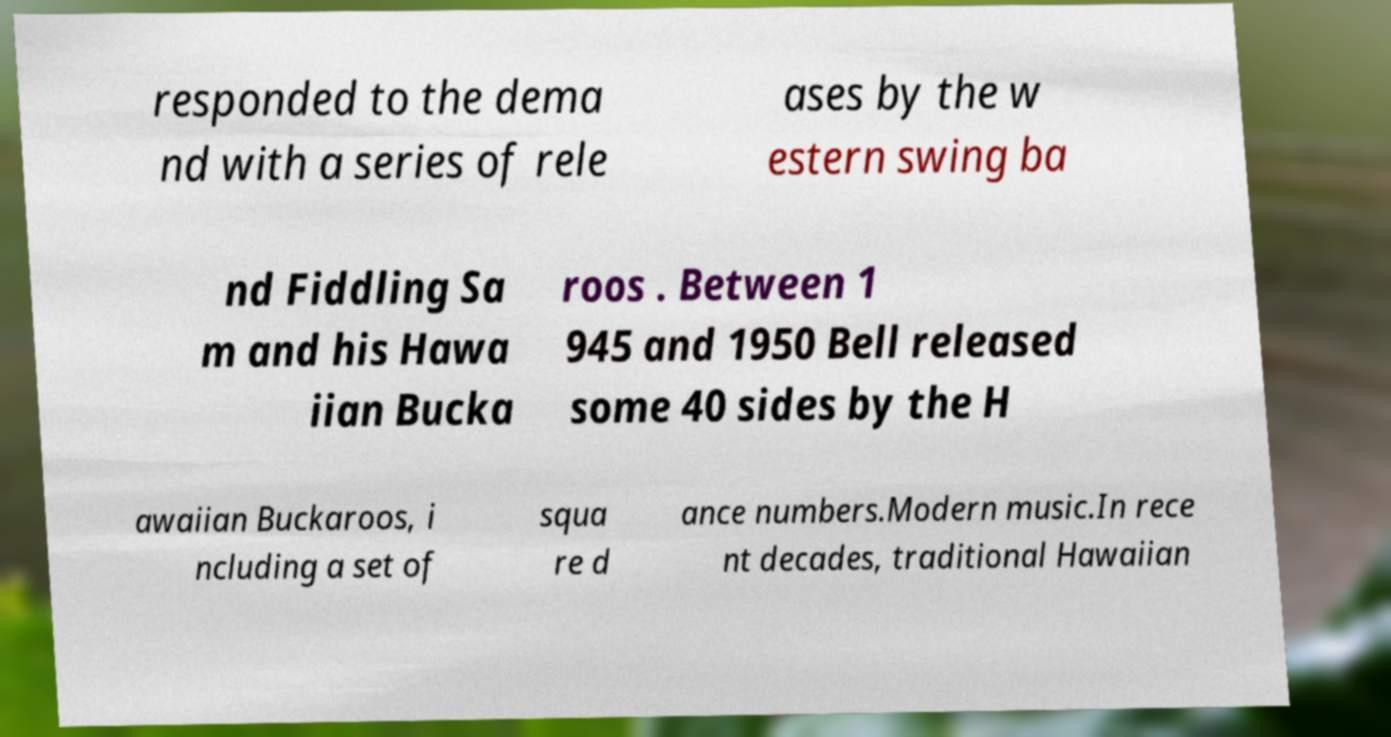Please identify and transcribe the text found in this image. responded to the dema nd with a series of rele ases by the w estern swing ba nd Fiddling Sa m and his Hawa iian Bucka roos . Between 1 945 and 1950 Bell released some 40 sides by the H awaiian Buckaroos, i ncluding a set of squa re d ance numbers.Modern music.In rece nt decades, traditional Hawaiian 